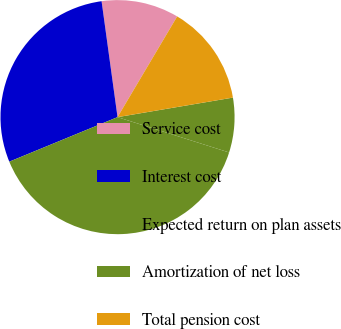<chart> <loc_0><loc_0><loc_500><loc_500><pie_chart><fcel>Service cost<fcel>Interest cost<fcel>Expected return on plan assets<fcel>Amortization of net loss<fcel>Total pension cost<nl><fcel>10.69%<fcel>29.04%<fcel>38.91%<fcel>7.55%<fcel>13.82%<nl></chart> 